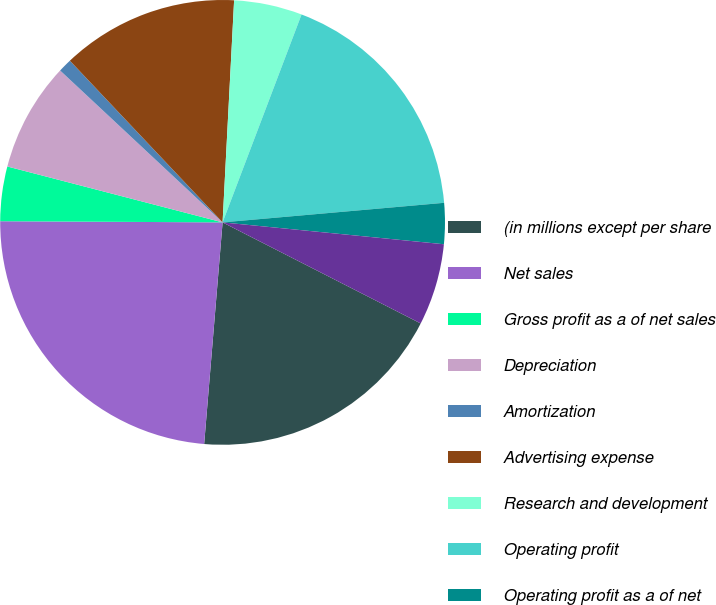Convert chart to OTSL. <chart><loc_0><loc_0><loc_500><loc_500><pie_chart><fcel>(in millions except per share<fcel>Net sales<fcel>Gross profit as a of net sales<fcel>Depreciation<fcel>Amortization<fcel>Advertising expense<fcel>Research and development<fcel>Operating profit<fcel>Operating profit as a of net<fcel>Interest expense<nl><fcel>18.81%<fcel>23.76%<fcel>3.96%<fcel>7.92%<fcel>0.99%<fcel>12.87%<fcel>4.95%<fcel>17.82%<fcel>2.97%<fcel>5.94%<nl></chart> 